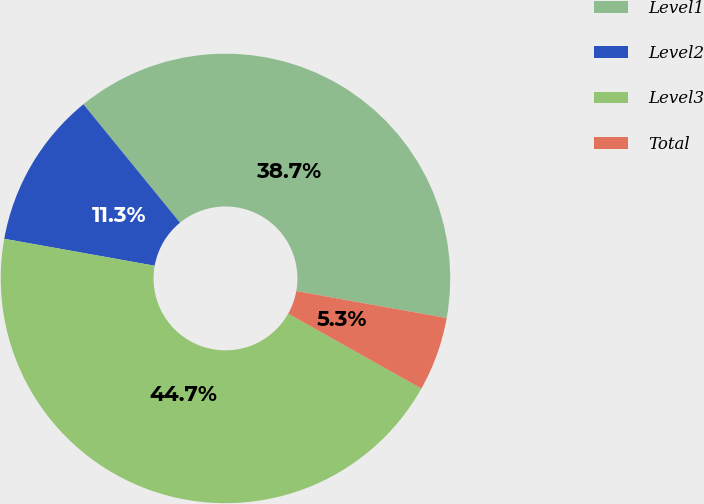Convert chart. <chart><loc_0><loc_0><loc_500><loc_500><pie_chart><fcel>Level1<fcel>Level2<fcel>Level3<fcel>Total<nl><fcel>38.71%<fcel>11.29%<fcel>44.67%<fcel>5.33%<nl></chart> 